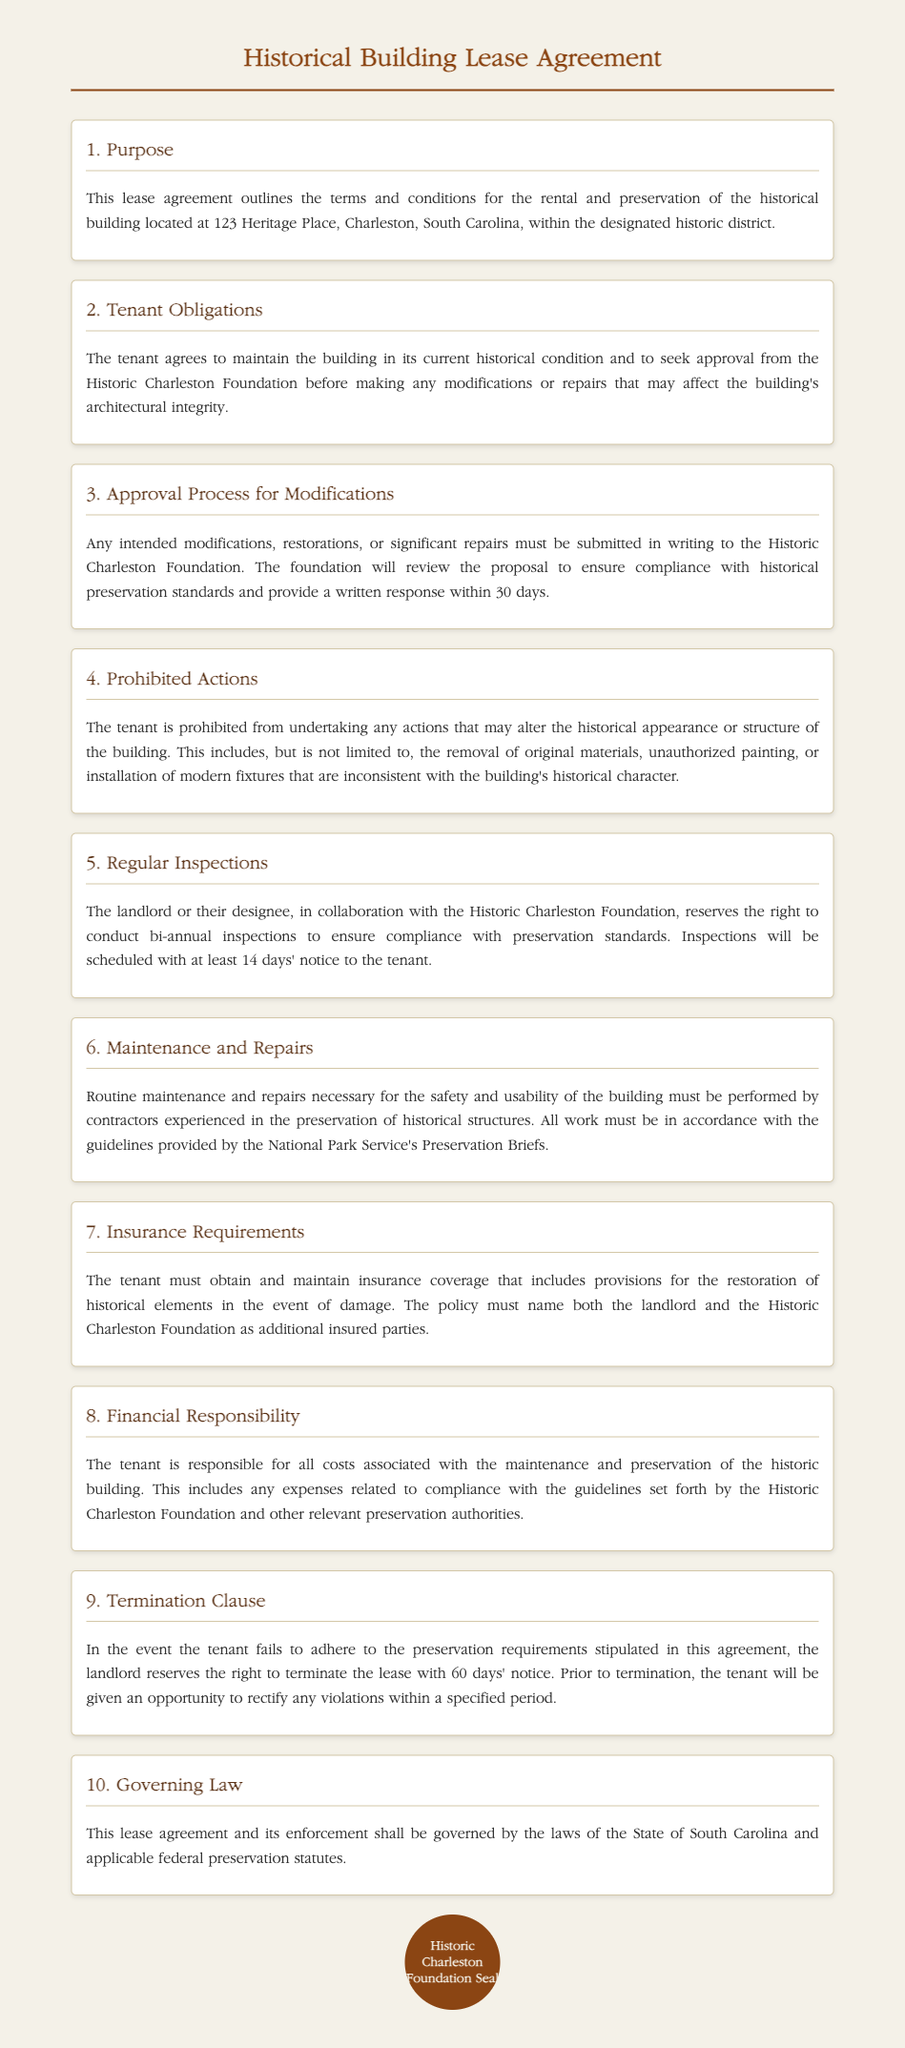What is the address of the historical building? The address is clearly mentioned in the Purpose section of the document.
Answer: 123 Heritage Place, Charleston, South Carolina What is required before making modifications to the building? The tenant must seek approval from the Historic Charleston Foundation before making any modifications.
Answer: Approval from the Historic Charleston Foundation How often are inspections conducted? The Regular Inspections section specifies the schedule for these inspections.
Answer: Bi-annual What type of contractors must perform maintenance? The Maintenance and Repairs section mentions the qualifications of contractors for maintenance.
Answer: Experienced in the preservation of historical structures What can happen if the tenant fails to adhere to preservation requirements? The Termination Clause details the consequences of not following the preservation requirements.
Answer: The landlord reserves the right to terminate the lease What law governs this lease agreement? The Governing Law section states the applicable jurisdiction for this lease.
Answer: The State of South Carolina 